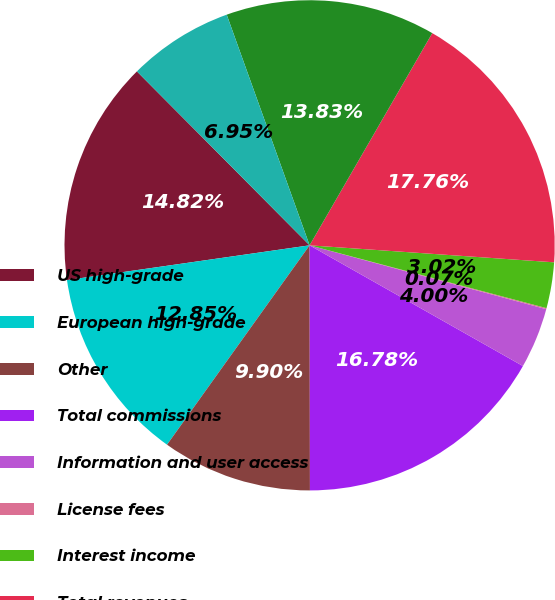<chart> <loc_0><loc_0><loc_500><loc_500><pie_chart><fcel>US high-grade<fcel>European high-grade<fcel>Other<fcel>Total commissions<fcel>Information and user access<fcel>License fees<fcel>Interest income<fcel>Total revenues<fcel>Employee compensation and<fcel>Depreciation and amortization<nl><fcel>14.82%<fcel>12.85%<fcel>9.9%<fcel>16.78%<fcel>4.0%<fcel>0.07%<fcel>3.02%<fcel>17.76%<fcel>13.83%<fcel>6.95%<nl></chart> 